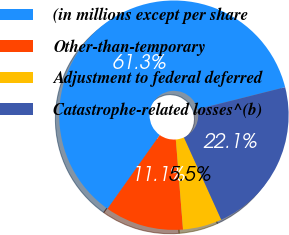<chart> <loc_0><loc_0><loc_500><loc_500><pie_chart><fcel>(in millions except per share<fcel>Other-than-temporary<fcel>Adjustment to federal deferred<fcel>Catastrophe-related losses^(b)<nl><fcel>61.27%<fcel>11.08%<fcel>5.51%<fcel>22.15%<nl></chart> 